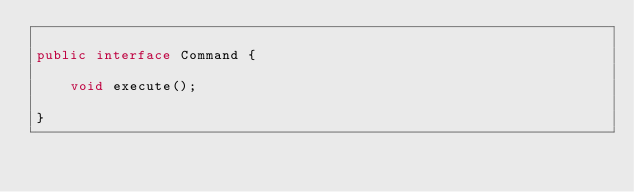Convert code to text. <code><loc_0><loc_0><loc_500><loc_500><_Java_>
public interface Command {

    void execute();

}
</code> 